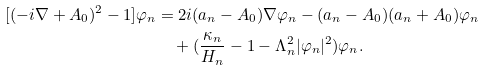Convert formula to latex. <formula><loc_0><loc_0><loc_500><loc_500>[ ( - i \nabla + { A } _ { 0 } ) ^ { 2 } - 1 ] \varphi _ { n } & = 2 i ( { a } _ { n } - { A } _ { 0 } ) \nabla \varphi _ { n } - ( { a } _ { n } - { A } _ { 0 } ) ( { a } _ { n } + { A } _ { 0 } ) \varphi _ { n } \\ & \quad + ( \frac { \kappa _ { n } } { H _ { n } } - 1 - \Lambda _ { n } ^ { 2 } | \varphi _ { n } | ^ { 2 } ) \varphi _ { n } .</formula> 